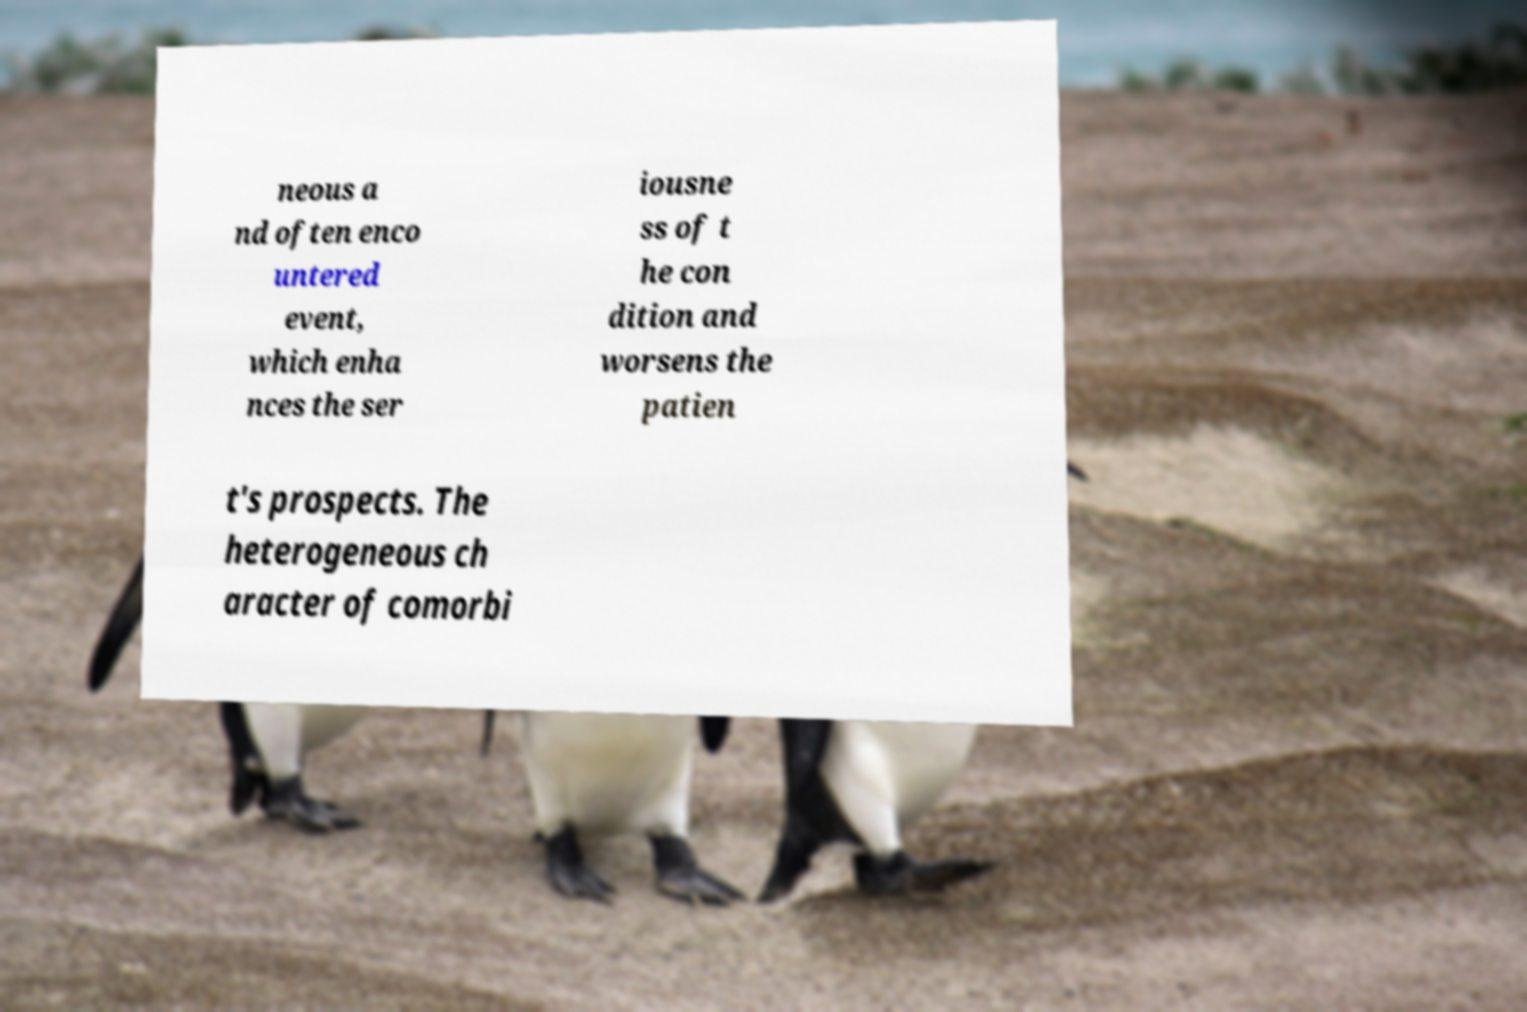What messages or text are displayed in this image? I need them in a readable, typed format. neous a nd often enco untered event, which enha nces the ser iousne ss of t he con dition and worsens the patien t's prospects. The heterogeneous ch aracter of comorbi 